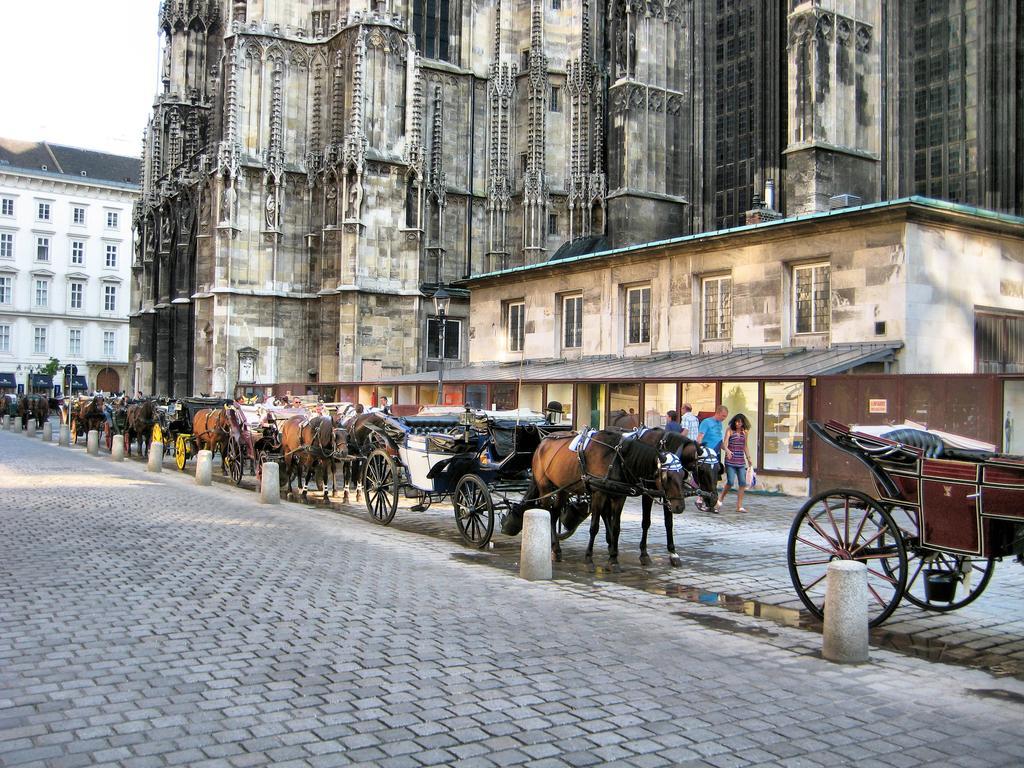Could you give a brief overview of what you see in this image? In this image we can see some horse carts and there are few people in the street and we can see some buildings. 